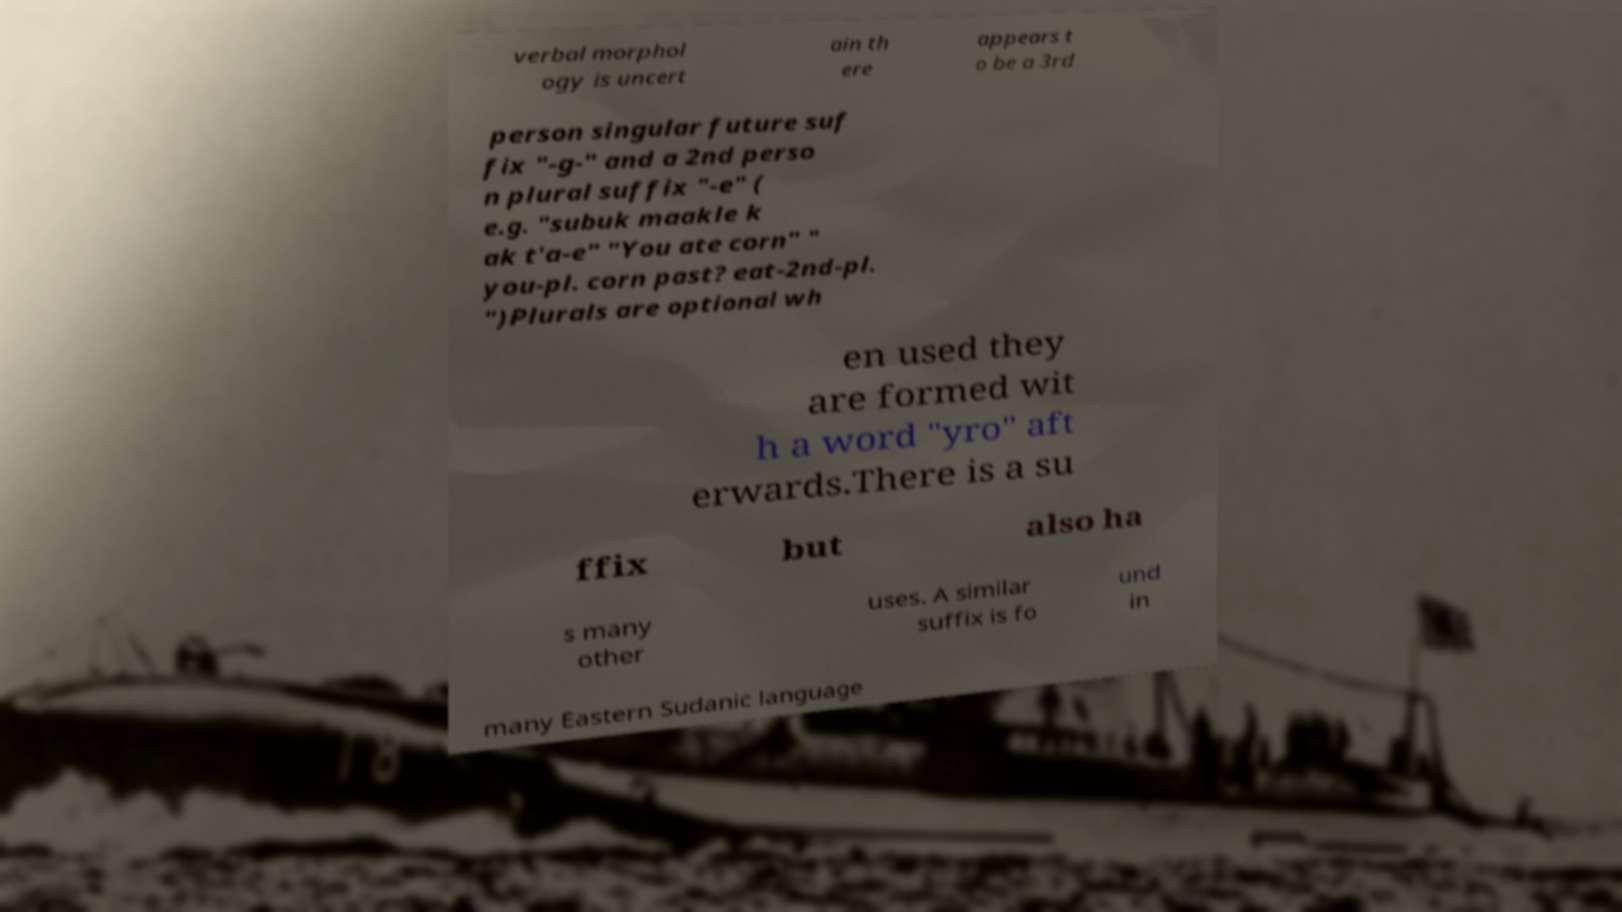Please read and relay the text visible in this image. What does it say? verbal morphol ogy is uncert ain th ere appears t o be a 3rd person singular future suf fix "-g-" and a 2nd perso n plural suffix "-e" ( e.g. "subuk maakle k ak t'a-e" "You ate corn" " you-pl. corn past? eat-2nd-pl. ")Plurals are optional wh en used they are formed wit h a word "yro" aft erwards.There is a su ffix but also ha s many other uses. A similar suffix is fo und in many Eastern Sudanic language 